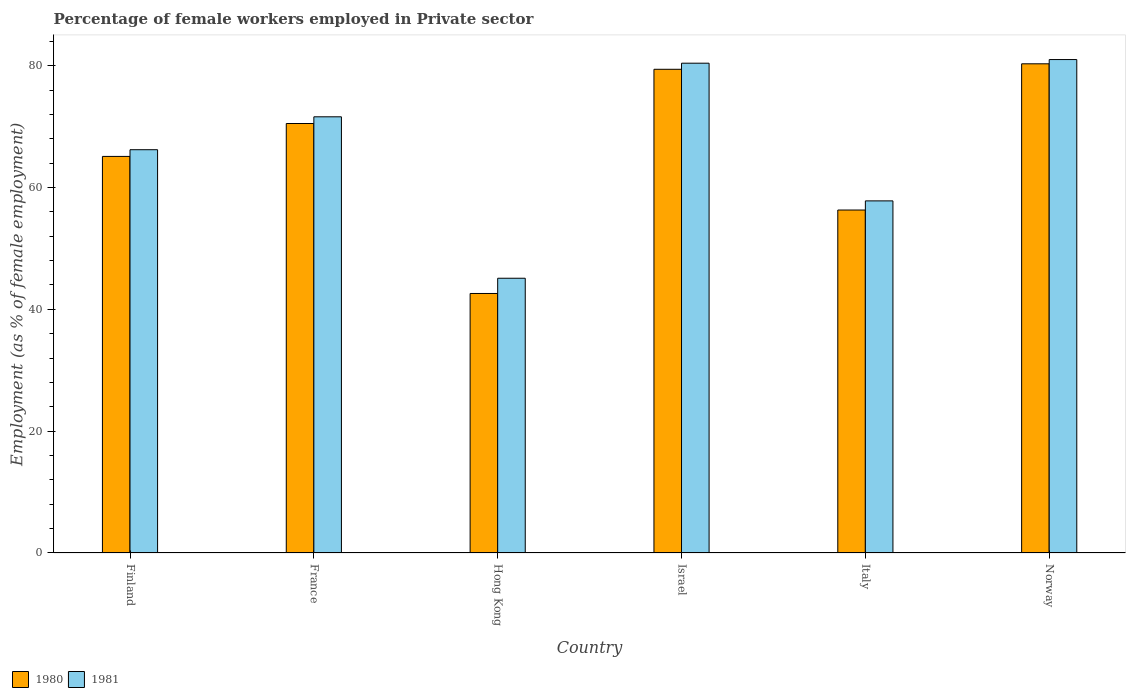How many groups of bars are there?
Provide a succinct answer. 6. Are the number of bars per tick equal to the number of legend labels?
Ensure brevity in your answer.  Yes. How many bars are there on the 3rd tick from the left?
Provide a succinct answer. 2. How many bars are there on the 2nd tick from the right?
Keep it short and to the point. 2. What is the label of the 1st group of bars from the left?
Give a very brief answer. Finland. In how many cases, is the number of bars for a given country not equal to the number of legend labels?
Provide a short and direct response. 0. What is the percentage of females employed in Private sector in 1980 in Hong Kong?
Ensure brevity in your answer.  42.6. Across all countries, what is the maximum percentage of females employed in Private sector in 1980?
Provide a succinct answer. 80.3. Across all countries, what is the minimum percentage of females employed in Private sector in 1981?
Give a very brief answer. 45.1. In which country was the percentage of females employed in Private sector in 1980 minimum?
Ensure brevity in your answer.  Hong Kong. What is the total percentage of females employed in Private sector in 1981 in the graph?
Provide a short and direct response. 402.1. What is the difference between the percentage of females employed in Private sector in 1981 in Hong Kong and that in Italy?
Your response must be concise. -12.7. What is the difference between the percentage of females employed in Private sector in 1980 in Norway and the percentage of females employed in Private sector in 1981 in Italy?
Keep it short and to the point. 22.5. What is the average percentage of females employed in Private sector in 1981 per country?
Provide a short and direct response. 67.02. What is the ratio of the percentage of females employed in Private sector in 1980 in Hong Kong to that in Norway?
Your response must be concise. 0.53. Is the percentage of females employed in Private sector in 1981 in France less than that in Italy?
Give a very brief answer. No. Is the difference between the percentage of females employed in Private sector in 1981 in France and Italy greater than the difference between the percentage of females employed in Private sector in 1980 in France and Italy?
Provide a short and direct response. No. What is the difference between the highest and the second highest percentage of females employed in Private sector in 1981?
Your response must be concise. -0.6. What is the difference between the highest and the lowest percentage of females employed in Private sector in 1980?
Keep it short and to the point. 37.7. What does the 1st bar from the left in France represents?
Keep it short and to the point. 1980. How many bars are there?
Make the answer very short. 12. How many countries are there in the graph?
Give a very brief answer. 6. What is the difference between two consecutive major ticks on the Y-axis?
Keep it short and to the point. 20. Are the values on the major ticks of Y-axis written in scientific E-notation?
Offer a terse response. No. How many legend labels are there?
Provide a succinct answer. 2. How are the legend labels stacked?
Your answer should be compact. Horizontal. What is the title of the graph?
Offer a very short reply. Percentage of female workers employed in Private sector. What is the label or title of the Y-axis?
Make the answer very short. Employment (as % of female employment). What is the Employment (as % of female employment) in 1980 in Finland?
Your answer should be compact. 65.1. What is the Employment (as % of female employment) of 1981 in Finland?
Provide a succinct answer. 66.2. What is the Employment (as % of female employment) in 1980 in France?
Your response must be concise. 70.5. What is the Employment (as % of female employment) in 1981 in France?
Offer a very short reply. 71.6. What is the Employment (as % of female employment) in 1980 in Hong Kong?
Give a very brief answer. 42.6. What is the Employment (as % of female employment) in 1981 in Hong Kong?
Provide a succinct answer. 45.1. What is the Employment (as % of female employment) of 1980 in Israel?
Provide a short and direct response. 79.4. What is the Employment (as % of female employment) in 1981 in Israel?
Give a very brief answer. 80.4. What is the Employment (as % of female employment) of 1980 in Italy?
Ensure brevity in your answer.  56.3. What is the Employment (as % of female employment) in 1981 in Italy?
Offer a very short reply. 57.8. What is the Employment (as % of female employment) of 1980 in Norway?
Ensure brevity in your answer.  80.3. What is the Employment (as % of female employment) of 1981 in Norway?
Your answer should be very brief. 81. Across all countries, what is the maximum Employment (as % of female employment) of 1980?
Ensure brevity in your answer.  80.3. Across all countries, what is the maximum Employment (as % of female employment) in 1981?
Provide a short and direct response. 81. Across all countries, what is the minimum Employment (as % of female employment) of 1980?
Provide a short and direct response. 42.6. Across all countries, what is the minimum Employment (as % of female employment) of 1981?
Offer a very short reply. 45.1. What is the total Employment (as % of female employment) in 1980 in the graph?
Your response must be concise. 394.2. What is the total Employment (as % of female employment) in 1981 in the graph?
Give a very brief answer. 402.1. What is the difference between the Employment (as % of female employment) of 1980 in Finland and that in France?
Give a very brief answer. -5.4. What is the difference between the Employment (as % of female employment) of 1981 in Finland and that in Hong Kong?
Provide a succinct answer. 21.1. What is the difference between the Employment (as % of female employment) in 1980 in Finland and that in Israel?
Your answer should be very brief. -14.3. What is the difference between the Employment (as % of female employment) of 1981 in Finland and that in Israel?
Your answer should be very brief. -14.2. What is the difference between the Employment (as % of female employment) of 1980 in Finland and that in Italy?
Make the answer very short. 8.8. What is the difference between the Employment (as % of female employment) in 1980 in Finland and that in Norway?
Provide a short and direct response. -15.2. What is the difference between the Employment (as % of female employment) in 1981 in Finland and that in Norway?
Provide a short and direct response. -14.8. What is the difference between the Employment (as % of female employment) of 1980 in France and that in Hong Kong?
Your response must be concise. 27.9. What is the difference between the Employment (as % of female employment) in 1981 in France and that in Israel?
Your answer should be compact. -8.8. What is the difference between the Employment (as % of female employment) in 1981 in France and that in Italy?
Your response must be concise. 13.8. What is the difference between the Employment (as % of female employment) of 1980 in France and that in Norway?
Give a very brief answer. -9.8. What is the difference between the Employment (as % of female employment) in 1980 in Hong Kong and that in Israel?
Give a very brief answer. -36.8. What is the difference between the Employment (as % of female employment) of 1981 in Hong Kong and that in Israel?
Provide a short and direct response. -35.3. What is the difference between the Employment (as % of female employment) in 1980 in Hong Kong and that in Italy?
Provide a succinct answer. -13.7. What is the difference between the Employment (as % of female employment) in 1981 in Hong Kong and that in Italy?
Provide a short and direct response. -12.7. What is the difference between the Employment (as % of female employment) in 1980 in Hong Kong and that in Norway?
Make the answer very short. -37.7. What is the difference between the Employment (as % of female employment) of 1981 in Hong Kong and that in Norway?
Offer a terse response. -35.9. What is the difference between the Employment (as % of female employment) of 1980 in Israel and that in Italy?
Offer a very short reply. 23.1. What is the difference between the Employment (as % of female employment) of 1981 in Israel and that in Italy?
Make the answer very short. 22.6. What is the difference between the Employment (as % of female employment) of 1981 in Italy and that in Norway?
Your answer should be compact. -23.2. What is the difference between the Employment (as % of female employment) in 1980 in Finland and the Employment (as % of female employment) in 1981 in Hong Kong?
Give a very brief answer. 20. What is the difference between the Employment (as % of female employment) in 1980 in Finland and the Employment (as % of female employment) in 1981 in Israel?
Your response must be concise. -15.3. What is the difference between the Employment (as % of female employment) in 1980 in Finland and the Employment (as % of female employment) in 1981 in Norway?
Your answer should be very brief. -15.9. What is the difference between the Employment (as % of female employment) in 1980 in France and the Employment (as % of female employment) in 1981 in Hong Kong?
Offer a very short reply. 25.4. What is the difference between the Employment (as % of female employment) in 1980 in France and the Employment (as % of female employment) in 1981 in Israel?
Offer a very short reply. -9.9. What is the difference between the Employment (as % of female employment) in 1980 in France and the Employment (as % of female employment) in 1981 in Norway?
Your answer should be very brief. -10.5. What is the difference between the Employment (as % of female employment) of 1980 in Hong Kong and the Employment (as % of female employment) of 1981 in Israel?
Provide a short and direct response. -37.8. What is the difference between the Employment (as % of female employment) in 1980 in Hong Kong and the Employment (as % of female employment) in 1981 in Italy?
Ensure brevity in your answer.  -15.2. What is the difference between the Employment (as % of female employment) in 1980 in Hong Kong and the Employment (as % of female employment) in 1981 in Norway?
Give a very brief answer. -38.4. What is the difference between the Employment (as % of female employment) of 1980 in Israel and the Employment (as % of female employment) of 1981 in Italy?
Make the answer very short. 21.6. What is the difference between the Employment (as % of female employment) in 1980 in Italy and the Employment (as % of female employment) in 1981 in Norway?
Offer a terse response. -24.7. What is the average Employment (as % of female employment) in 1980 per country?
Offer a very short reply. 65.7. What is the average Employment (as % of female employment) in 1981 per country?
Offer a very short reply. 67.02. What is the difference between the Employment (as % of female employment) in 1980 and Employment (as % of female employment) in 1981 in France?
Ensure brevity in your answer.  -1.1. What is the difference between the Employment (as % of female employment) in 1980 and Employment (as % of female employment) in 1981 in Israel?
Give a very brief answer. -1. What is the difference between the Employment (as % of female employment) in 1980 and Employment (as % of female employment) in 1981 in Norway?
Your answer should be very brief. -0.7. What is the ratio of the Employment (as % of female employment) in 1980 in Finland to that in France?
Provide a short and direct response. 0.92. What is the ratio of the Employment (as % of female employment) of 1981 in Finland to that in France?
Keep it short and to the point. 0.92. What is the ratio of the Employment (as % of female employment) of 1980 in Finland to that in Hong Kong?
Make the answer very short. 1.53. What is the ratio of the Employment (as % of female employment) of 1981 in Finland to that in Hong Kong?
Offer a very short reply. 1.47. What is the ratio of the Employment (as % of female employment) of 1980 in Finland to that in Israel?
Your response must be concise. 0.82. What is the ratio of the Employment (as % of female employment) in 1981 in Finland to that in Israel?
Keep it short and to the point. 0.82. What is the ratio of the Employment (as % of female employment) in 1980 in Finland to that in Italy?
Offer a very short reply. 1.16. What is the ratio of the Employment (as % of female employment) of 1981 in Finland to that in Italy?
Your response must be concise. 1.15. What is the ratio of the Employment (as % of female employment) of 1980 in Finland to that in Norway?
Ensure brevity in your answer.  0.81. What is the ratio of the Employment (as % of female employment) in 1981 in Finland to that in Norway?
Offer a terse response. 0.82. What is the ratio of the Employment (as % of female employment) of 1980 in France to that in Hong Kong?
Your response must be concise. 1.65. What is the ratio of the Employment (as % of female employment) in 1981 in France to that in Hong Kong?
Your response must be concise. 1.59. What is the ratio of the Employment (as % of female employment) of 1980 in France to that in Israel?
Offer a very short reply. 0.89. What is the ratio of the Employment (as % of female employment) in 1981 in France to that in Israel?
Provide a short and direct response. 0.89. What is the ratio of the Employment (as % of female employment) of 1980 in France to that in Italy?
Make the answer very short. 1.25. What is the ratio of the Employment (as % of female employment) in 1981 in France to that in Italy?
Provide a succinct answer. 1.24. What is the ratio of the Employment (as % of female employment) of 1980 in France to that in Norway?
Keep it short and to the point. 0.88. What is the ratio of the Employment (as % of female employment) in 1981 in France to that in Norway?
Offer a terse response. 0.88. What is the ratio of the Employment (as % of female employment) of 1980 in Hong Kong to that in Israel?
Provide a succinct answer. 0.54. What is the ratio of the Employment (as % of female employment) in 1981 in Hong Kong to that in Israel?
Make the answer very short. 0.56. What is the ratio of the Employment (as % of female employment) of 1980 in Hong Kong to that in Italy?
Provide a short and direct response. 0.76. What is the ratio of the Employment (as % of female employment) of 1981 in Hong Kong to that in Italy?
Offer a very short reply. 0.78. What is the ratio of the Employment (as % of female employment) in 1980 in Hong Kong to that in Norway?
Your answer should be very brief. 0.53. What is the ratio of the Employment (as % of female employment) in 1981 in Hong Kong to that in Norway?
Ensure brevity in your answer.  0.56. What is the ratio of the Employment (as % of female employment) in 1980 in Israel to that in Italy?
Your response must be concise. 1.41. What is the ratio of the Employment (as % of female employment) of 1981 in Israel to that in Italy?
Offer a very short reply. 1.39. What is the ratio of the Employment (as % of female employment) in 1980 in Italy to that in Norway?
Give a very brief answer. 0.7. What is the ratio of the Employment (as % of female employment) in 1981 in Italy to that in Norway?
Provide a succinct answer. 0.71. What is the difference between the highest and the lowest Employment (as % of female employment) in 1980?
Offer a very short reply. 37.7. What is the difference between the highest and the lowest Employment (as % of female employment) in 1981?
Your answer should be very brief. 35.9. 